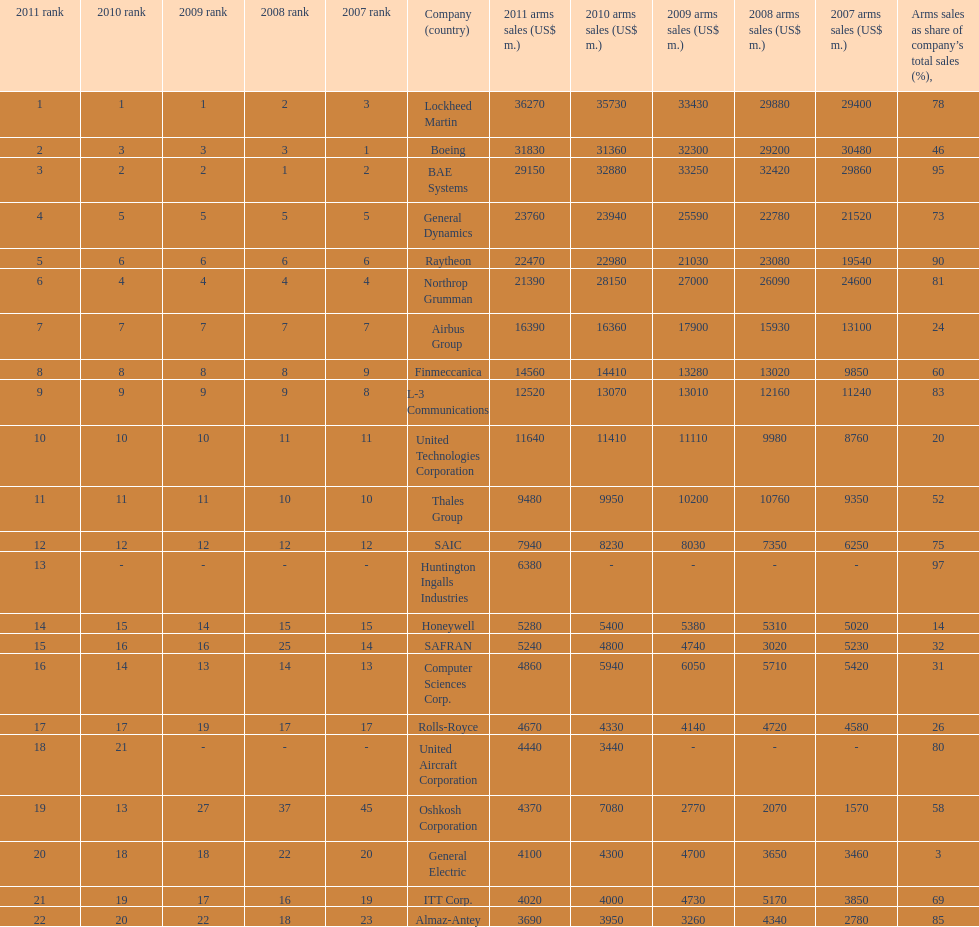Calculate the difference between boeing's 2010 arms sales and raytheon's 2010 arms sales. 8380. 